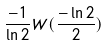<formula> <loc_0><loc_0><loc_500><loc_500>\frac { - 1 } { \ln 2 } W ( \frac { - \ln 2 } { 2 } )</formula> 